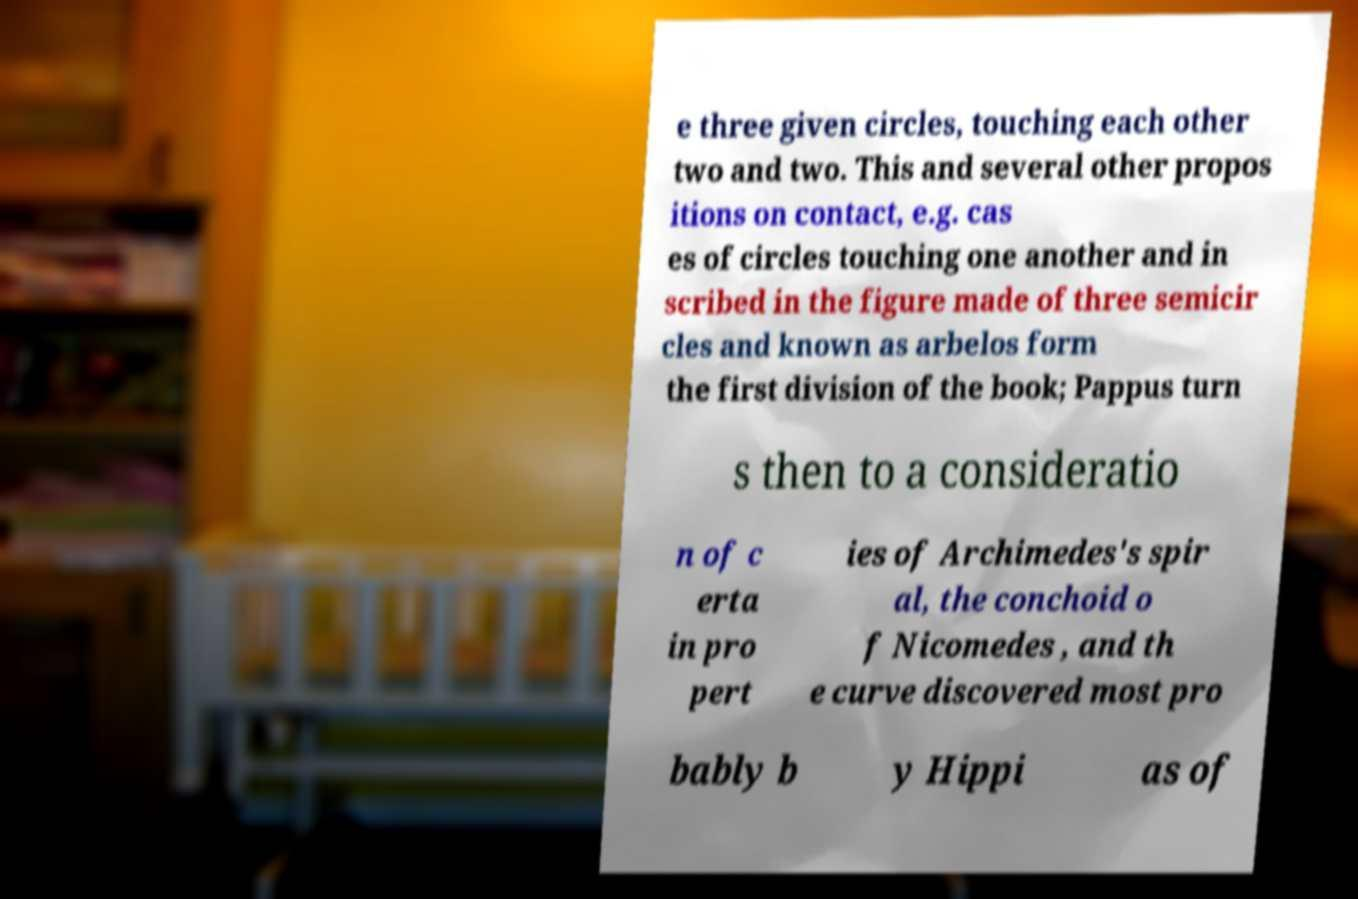For documentation purposes, I need the text within this image transcribed. Could you provide that? e three given circles, touching each other two and two. This and several other propos itions on contact, e.g. cas es of circles touching one another and in scribed in the figure made of three semicir cles and known as arbelos form the first division of the book; Pappus turn s then to a consideratio n of c erta in pro pert ies of Archimedes's spir al, the conchoid o f Nicomedes , and th e curve discovered most pro bably b y Hippi as of 